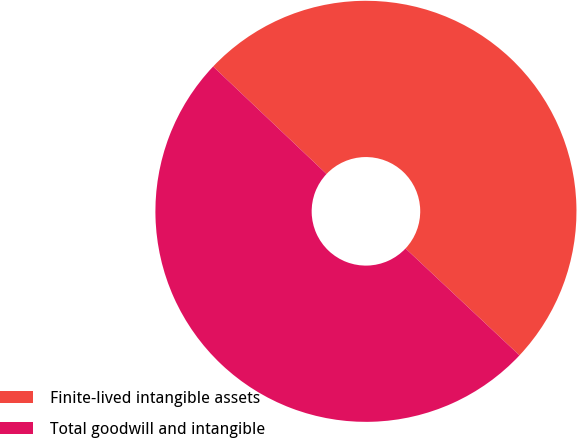<chart> <loc_0><loc_0><loc_500><loc_500><pie_chart><fcel>Finite-lived intangible assets<fcel>Total goodwill and intangible<nl><fcel>49.92%<fcel>50.08%<nl></chart> 